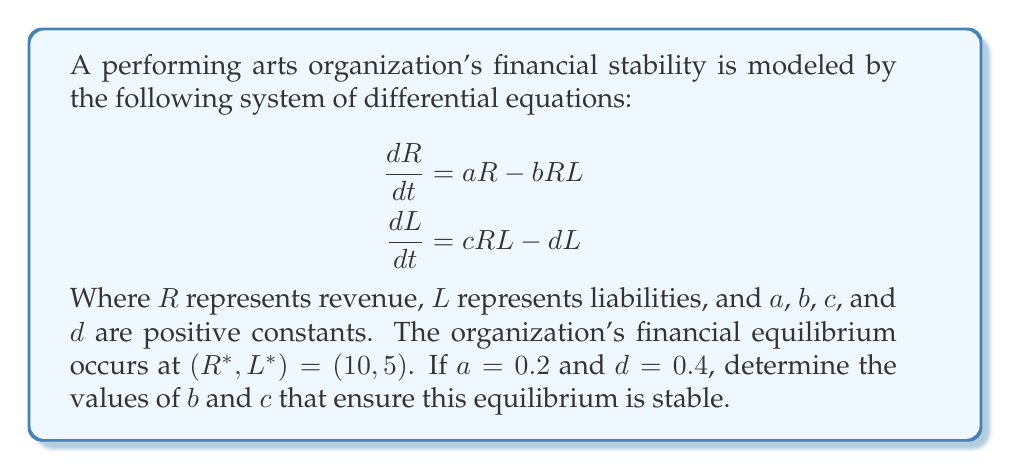Can you answer this question? To analyze the stability of the system, we need to follow these steps:

1) First, we need to find the Jacobian matrix of the system at the equilibrium point:

   $$J = \begin{bmatrix}
   \frac{\partial}{\partial R}(aR - bRL) & \frac{\partial}{\partial L}(aR - bRL) \\
   \frac{\partial}{\partial R}(cRL - dL) & \frac{\partial}{\partial L}(cRL - dL)
   \end{bmatrix}_{(R^*, L^*)}$$

   $$J = \begin{bmatrix}
   a - bL^* & -bR^* \\
   cL^* & cR^* - d
   \end{bmatrix}_{(10, 5)}$$

2) Substituting the given values:

   $$J = \begin{bmatrix}
   0.2 - 5b & -10b \\
   5c & 10c - 0.4
   \end{bmatrix}$$

3) For the equilibrium to be stable, the trace of J must be negative and the determinant of J must be positive. Let's express these conditions:

   Trace(J) = $(0.2 - 5b) + (10c - 0.4) < 0$
   Det(J) = $(0.2 - 5b)(10c - 0.4) - (-10b)(5c) > 0$

4) Simplifying the trace condition:
   $10c - 5b - 0.2 < 0$
   $10c - 5b < 0.2$

5) Simplifying the determinant condition:
   $(2 - 50b)(10c - 0.4) + 50bc > 0$
   $20c - 0.8 - 500bc + 20b + 50bc > 0$
   $20c + 20b - 450bc - 0.8 > 0$

6) We now have a system of inequalities:
   $10c - 5b < 0.2$
   $20c + 20b - 450bc - 0.8 > 0$

7) To ensure stability, we need to find values of $b$ and $c$ that satisfy both inequalities. One possible solution is:

   $b = 0.04$ and $c = 0.02$

   These values satisfy both inequalities:
   $10(0.02) - 5(0.04) = 0 < 0.2$
   $20(0.02) + 20(0.04) - 450(0.04)(0.02) - 0.8 = 0.44 > 0$
Answer: $b = 0.04$, $c = 0.02$ 